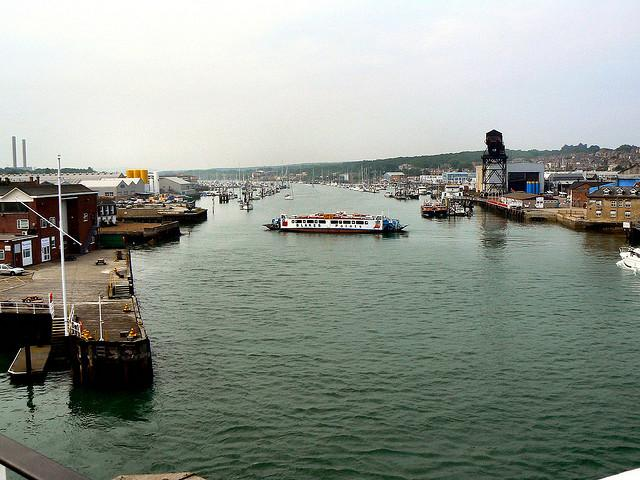What color are the end bridges for the boat suspended in the middle of the river?

Choices:
A) blue
B) white
C) red
D) green blue 